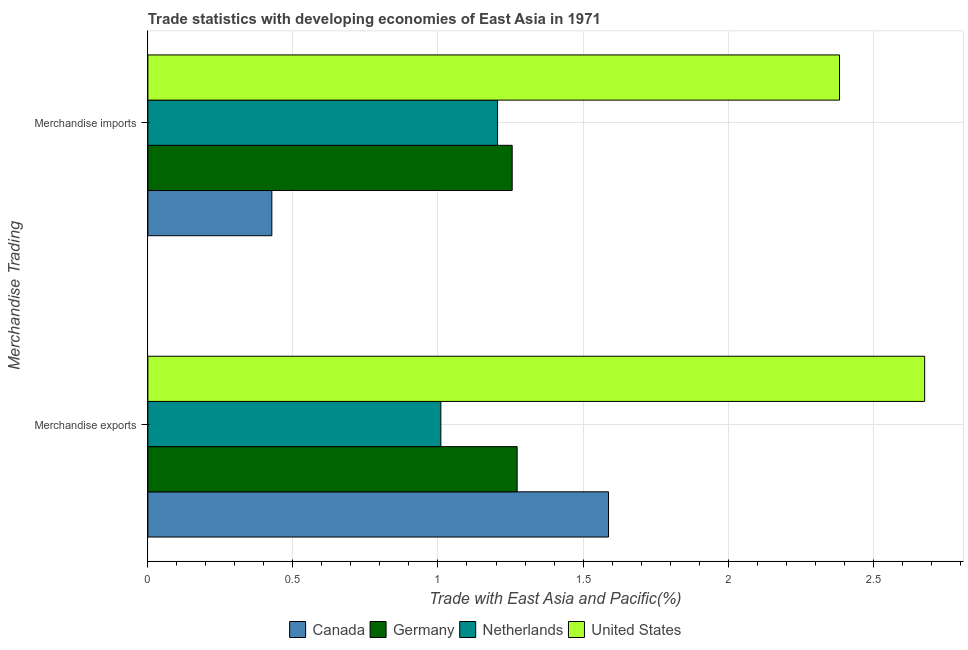How many groups of bars are there?
Keep it short and to the point. 2. Are the number of bars per tick equal to the number of legend labels?
Make the answer very short. Yes. How many bars are there on the 1st tick from the top?
Keep it short and to the point. 4. What is the merchandise exports in United States?
Your response must be concise. 2.68. Across all countries, what is the maximum merchandise exports?
Ensure brevity in your answer.  2.68. Across all countries, what is the minimum merchandise exports?
Provide a succinct answer. 1.01. In which country was the merchandise imports maximum?
Your answer should be compact. United States. In which country was the merchandise imports minimum?
Your answer should be very brief. Canada. What is the total merchandise imports in the graph?
Keep it short and to the point. 5.27. What is the difference between the merchandise exports in Germany and that in Netherlands?
Make the answer very short. 0.26. What is the difference between the merchandise exports in Germany and the merchandise imports in United States?
Your answer should be compact. -1.11. What is the average merchandise imports per country?
Offer a very short reply. 1.32. What is the difference between the merchandise imports and merchandise exports in Germany?
Keep it short and to the point. -0.02. What is the ratio of the merchandise exports in Netherlands to that in United States?
Offer a terse response. 0.38. Is the merchandise imports in Germany less than that in Netherlands?
Provide a succinct answer. No. In how many countries, is the merchandise exports greater than the average merchandise exports taken over all countries?
Offer a very short reply. 1. What does the 3rd bar from the bottom in Merchandise exports represents?
Your response must be concise. Netherlands. Are the values on the major ticks of X-axis written in scientific E-notation?
Your answer should be very brief. No. Does the graph contain any zero values?
Your answer should be compact. No. What is the title of the graph?
Make the answer very short. Trade statistics with developing economies of East Asia in 1971. Does "Uganda" appear as one of the legend labels in the graph?
Your answer should be compact. No. What is the label or title of the X-axis?
Offer a terse response. Trade with East Asia and Pacific(%). What is the label or title of the Y-axis?
Your answer should be very brief. Merchandise Trading. What is the Trade with East Asia and Pacific(%) of Canada in Merchandise exports?
Make the answer very short. 1.59. What is the Trade with East Asia and Pacific(%) of Germany in Merchandise exports?
Keep it short and to the point. 1.27. What is the Trade with East Asia and Pacific(%) in Netherlands in Merchandise exports?
Your answer should be very brief. 1.01. What is the Trade with East Asia and Pacific(%) in United States in Merchandise exports?
Your answer should be very brief. 2.68. What is the Trade with East Asia and Pacific(%) in Canada in Merchandise imports?
Your answer should be very brief. 0.43. What is the Trade with East Asia and Pacific(%) in Germany in Merchandise imports?
Your answer should be very brief. 1.26. What is the Trade with East Asia and Pacific(%) in Netherlands in Merchandise imports?
Your answer should be very brief. 1.21. What is the Trade with East Asia and Pacific(%) of United States in Merchandise imports?
Your answer should be very brief. 2.38. Across all Merchandise Trading, what is the maximum Trade with East Asia and Pacific(%) of Canada?
Your response must be concise. 1.59. Across all Merchandise Trading, what is the maximum Trade with East Asia and Pacific(%) of Germany?
Your response must be concise. 1.27. Across all Merchandise Trading, what is the maximum Trade with East Asia and Pacific(%) of Netherlands?
Offer a very short reply. 1.21. Across all Merchandise Trading, what is the maximum Trade with East Asia and Pacific(%) in United States?
Give a very brief answer. 2.68. Across all Merchandise Trading, what is the minimum Trade with East Asia and Pacific(%) of Canada?
Keep it short and to the point. 0.43. Across all Merchandise Trading, what is the minimum Trade with East Asia and Pacific(%) of Germany?
Offer a very short reply. 1.26. Across all Merchandise Trading, what is the minimum Trade with East Asia and Pacific(%) of Netherlands?
Offer a terse response. 1.01. Across all Merchandise Trading, what is the minimum Trade with East Asia and Pacific(%) in United States?
Give a very brief answer. 2.38. What is the total Trade with East Asia and Pacific(%) of Canada in the graph?
Offer a very short reply. 2.02. What is the total Trade with East Asia and Pacific(%) in Germany in the graph?
Ensure brevity in your answer.  2.53. What is the total Trade with East Asia and Pacific(%) of Netherlands in the graph?
Your answer should be compact. 2.22. What is the total Trade with East Asia and Pacific(%) in United States in the graph?
Provide a short and direct response. 5.06. What is the difference between the Trade with East Asia and Pacific(%) of Canada in Merchandise exports and that in Merchandise imports?
Keep it short and to the point. 1.16. What is the difference between the Trade with East Asia and Pacific(%) in Germany in Merchandise exports and that in Merchandise imports?
Offer a very short reply. 0.02. What is the difference between the Trade with East Asia and Pacific(%) of Netherlands in Merchandise exports and that in Merchandise imports?
Offer a very short reply. -0.2. What is the difference between the Trade with East Asia and Pacific(%) in United States in Merchandise exports and that in Merchandise imports?
Offer a terse response. 0.29. What is the difference between the Trade with East Asia and Pacific(%) of Canada in Merchandise exports and the Trade with East Asia and Pacific(%) of Germany in Merchandise imports?
Offer a terse response. 0.33. What is the difference between the Trade with East Asia and Pacific(%) in Canada in Merchandise exports and the Trade with East Asia and Pacific(%) in Netherlands in Merchandise imports?
Your answer should be very brief. 0.38. What is the difference between the Trade with East Asia and Pacific(%) in Canada in Merchandise exports and the Trade with East Asia and Pacific(%) in United States in Merchandise imports?
Offer a very short reply. -0.8. What is the difference between the Trade with East Asia and Pacific(%) of Germany in Merchandise exports and the Trade with East Asia and Pacific(%) of Netherlands in Merchandise imports?
Your answer should be very brief. 0.07. What is the difference between the Trade with East Asia and Pacific(%) in Germany in Merchandise exports and the Trade with East Asia and Pacific(%) in United States in Merchandise imports?
Keep it short and to the point. -1.11. What is the difference between the Trade with East Asia and Pacific(%) of Netherlands in Merchandise exports and the Trade with East Asia and Pacific(%) of United States in Merchandise imports?
Provide a succinct answer. -1.37. What is the average Trade with East Asia and Pacific(%) in Canada per Merchandise Trading?
Your answer should be compact. 1.01. What is the average Trade with East Asia and Pacific(%) in Germany per Merchandise Trading?
Your answer should be very brief. 1.26. What is the average Trade with East Asia and Pacific(%) in Netherlands per Merchandise Trading?
Provide a short and direct response. 1.11. What is the average Trade with East Asia and Pacific(%) of United States per Merchandise Trading?
Your response must be concise. 2.53. What is the difference between the Trade with East Asia and Pacific(%) of Canada and Trade with East Asia and Pacific(%) of Germany in Merchandise exports?
Provide a succinct answer. 0.31. What is the difference between the Trade with East Asia and Pacific(%) in Canada and Trade with East Asia and Pacific(%) in Netherlands in Merchandise exports?
Your answer should be compact. 0.58. What is the difference between the Trade with East Asia and Pacific(%) in Canada and Trade with East Asia and Pacific(%) in United States in Merchandise exports?
Offer a very short reply. -1.09. What is the difference between the Trade with East Asia and Pacific(%) in Germany and Trade with East Asia and Pacific(%) in Netherlands in Merchandise exports?
Ensure brevity in your answer.  0.26. What is the difference between the Trade with East Asia and Pacific(%) in Germany and Trade with East Asia and Pacific(%) in United States in Merchandise exports?
Provide a succinct answer. -1.4. What is the difference between the Trade with East Asia and Pacific(%) of Netherlands and Trade with East Asia and Pacific(%) of United States in Merchandise exports?
Offer a terse response. -1.67. What is the difference between the Trade with East Asia and Pacific(%) of Canada and Trade with East Asia and Pacific(%) of Germany in Merchandise imports?
Keep it short and to the point. -0.83. What is the difference between the Trade with East Asia and Pacific(%) of Canada and Trade with East Asia and Pacific(%) of Netherlands in Merchandise imports?
Ensure brevity in your answer.  -0.78. What is the difference between the Trade with East Asia and Pacific(%) in Canada and Trade with East Asia and Pacific(%) in United States in Merchandise imports?
Provide a succinct answer. -1.96. What is the difference between the Trade with East Asia and Pacific(%) of Germany and Trade with East Asia and Pacific(%) of Netherlands in Merchandise imports?
Offer a very short reply. 0.05. What is the difference between the Trade with East Asia and Pacific(%) in Germany and Trade with East Asia and Pacific(%) in United States in Merchandise imports?
Ensure brevity in your answer.  -1.13. What is the difference between the Trade with East Asia and Pacific(%) of Netherlands and Trade with East Asia and Pacific(%) of United States in Merchandise imports?
Keep it short and to the point. -1.18. What is the ratio of the Trade with East Asia and Pacific(%) in Canada in Merchandise exports to that in Merchandise imports?
Your answer should be compact. 3.72. What is the ratio of the Trade with East Asia and Pacific(%) in Germany in Merchandise exports to that in Merchandise imports?
Your answer should be compact. 1.01. What is the ratio of the Trade with East Asia and Pacific(%) of Netherlands in Merchandise exports to that in Merchandise imports?
Ensure brevity in your answer.  0.84. What is the ratio of the Trade with East Asia and Pacific(%) in United States in Merchandise exports to that in Merchandise imports?
Offer a very short reply. 1.12. What is the difference between the highest and the second highest Trade with East Asia and Pacific(%) of Canada?
Make the answer very short. 1.16. What is the difference between the highest and the second highest Trade with East Asia and Pacific(%) in Germany?
Provide a short and direct response. 0.02. What is the difference between the highest and the second highest Trade with East Asia and Pacific(%) in Netherlands?
Your response must be concise. 0.2. What is the difference between the highest and the second highest Trade with East Asia and Pacific(%) in United States?
Keep it short and to the point. 0.29. What is the difference between the highest and the lowest Trade with East Asia and Pacific(%) in Canada?
Your answer should be compact. 1.16. What is the difference between the highest and the lowest Trade with East Asia and Pacific(%) of Germany?
Offer a terse response. 0.02. What is the difference between the highest and the lowest Trade with East Asia and Pacific(%) in Netherlands?
Give a very brief answer. 0.2. What is the difference between the highest and the lowest Trade with East Asia and Pacific(%) in United States?
Provide a short and direct response. 0.29. 